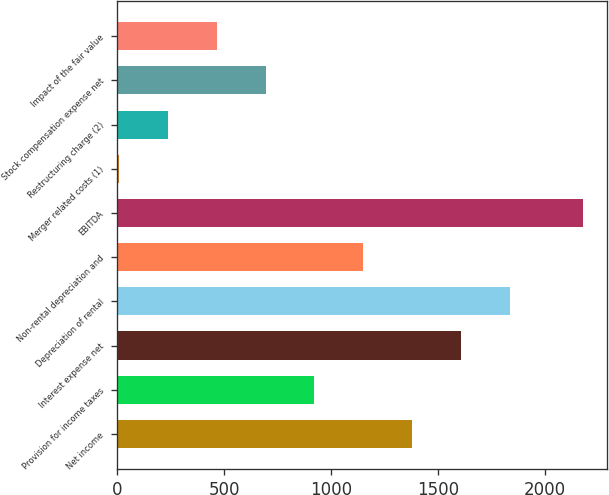Convert chart. <chart><loc_0><loc_0><loc_500><loc_500><bar_chart><fcel>Net income<fcel>Provision for income taxes<fcel>Interest expense net<fcel>Depreciation of rental<fcel>Non-rental depreciation and<fcel>EBITDA<fcel>Merger related costs (1)<fcel>Restructuring charge (2)<fcel>Stock compensation expense net<fcel>Impact of the fair value<nl><fcel>1379.4<fcel>922.6<fcel>1607.8<fcel>1836.2<fcel>1151<fcel>2181<fcel>9<fcel>237.4<fcel>694.2<fcel>465.8<nl></chart> 